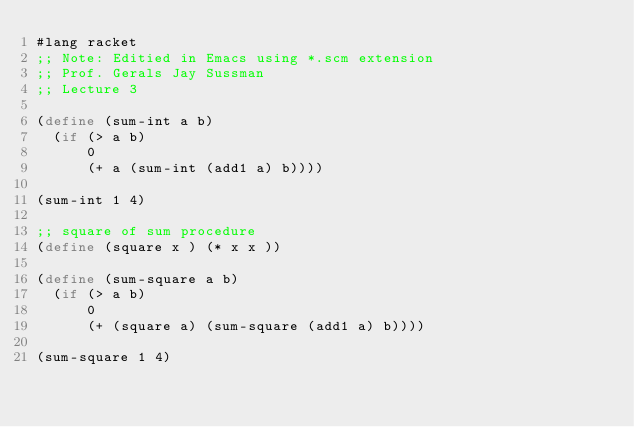Convert code to text. <code><loc_0><loc_0><loc_500><loc_500><_Scheme_>#lang racket
;; Note: Editied in Emacs using *.scm extension
;; Prof. Gerals Jay Sussman
;; Lecture 3

(define (sum-int a b)
  (if (> a b)
      0
      (+ a (sum-int (add1 a) b))))

(sum-int 1 4)

;; square of sum procedure
(define (square x ) (* x x ))

(define (sum-square a b)
  (if (> a b)
      0
      (+ (square a) (sum-square (add1 a) b))))

(sum-square 1 4)

</code> 